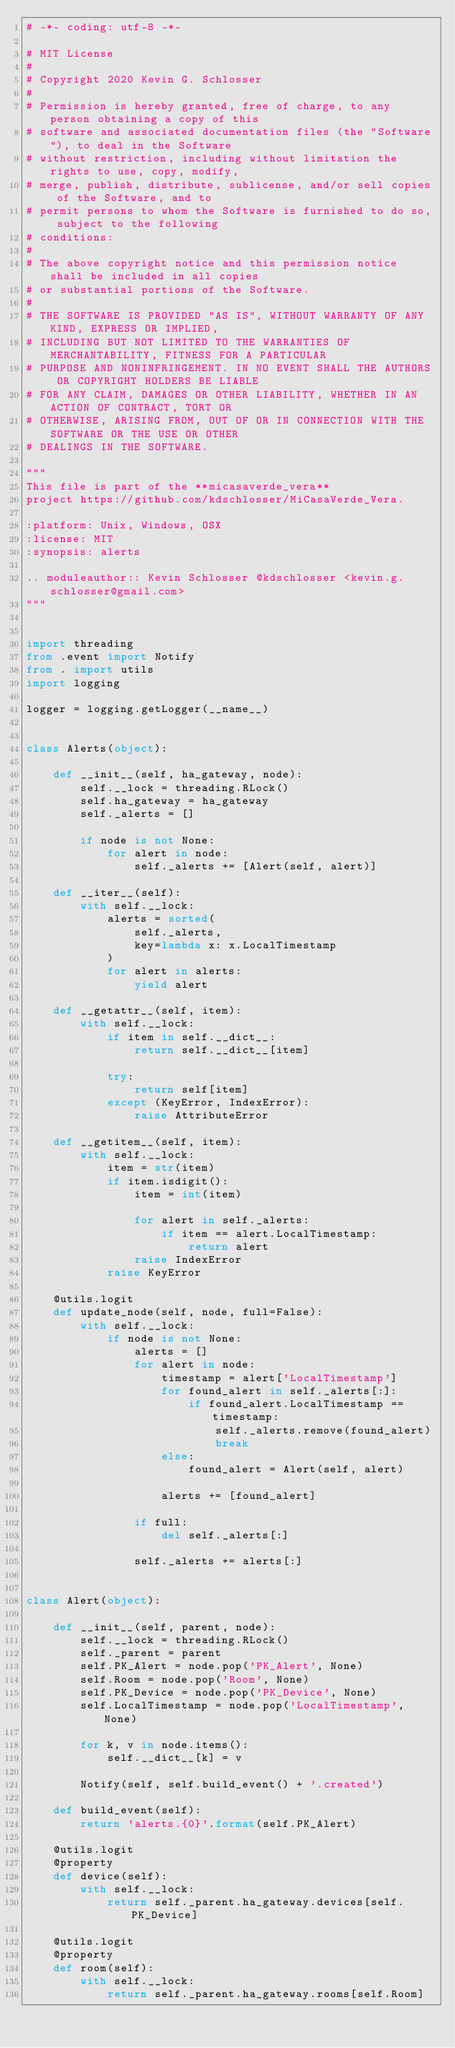Convert code to text. <code><loc_0><loc_0><loc_500><loc_500><_Python_># -*- coding: utf-8 -*-

# MIT License
#
# Copyright 2020 Kevin G. Schlosser
#
# Permission is hereby granted, free of charge, to any person obtaining a copy of this
# software and associated documentation files (the "Software"), to deal in the Software
# without restriction, including without limitation the rights to use, copy, modify,
# merge, publish, distribute, sublicense, and/or sell copies of the Software, and to
# permit persons to whom the Software is furnished to do so, subject to the following
# conditions:
#
# The above copyright notice and this permission notice shall be included in all copies
# or substantial portions of the Software.
#
# THE SOFTWARE IS PROVIDED "AS IS", WITHOUT WARRANTY OF ANY KIND, EXPRESS OR IMPLIED,
# INCLUDING BUT NOT LIMITED TO THE WARRANTIES OF MERCHANTABILITY, FITNESS FOR A PARTICULAR
# PURPOSE AND NONINFRINGEMENT. IN NO EVENT SHALL THE AUTHORS OR COPYRIGHT HOLDERS BE LIABLE
# FOR ANY CLAIM, DAMAGES OR OTHER LIABILITY, WHETHER IN AN ACTION OF CONTRACT, TORT OR
# OTHERWISE, ARISING FROM, OUT OF OR IN CONNECTION WITH THE SOFTWARE OR THE USE OR OTHER
# DEALINGS IN THE SOFTWARE.

"""
This file is part of the **micasaverde_vera**
project https://github.com/kdschlosser/MiCasaVerde_Vera.

:platform: Unix, Windows, OSX
:license: MIT
:synopsis: alerts

.. moduleauthor:: Kevin Schlosser @kdschlosser <kevin.g.schlosser@gmail.com>
"""


import threading
from .event import Notify
from . import utils
import logging

logger = logging.getLogger(__name__)


class Alerts(object):

    def __init__(self, ha_gateway, node):
        self.__lock = threading.RLock()
        self.ha_gateway = ha_gateway
        self._alerts = []

        if node is not None:
            for alert in node:
                self._alerts += [Alert(self, alert)]

    def __iter__(self):
        with self.__lock:
            alerts = sorted(
                self._alerts,
                key=lambda x: x.LocalTimestamp
            )
            for alert in alerts:
                yield alert

    def __getattr__(self, item):
        with self.__lock:
            if item in self.__dict__:
                return self.__dict__[item]

            try:
                return self[item]
            except (KeyError, IndexError):
                raise AttributeError

    def __getitem__(self, item):
        with self.__lock:
            item = str(item)
            if item.isdigit():
                item = int(item)

                for alert in self._alerts:
                    if item == alert.LocalTimestamp:
                        return alert
                raise IndexError
            raise KeyError

    @utils.logit
    def update_node(self, node, full=False):
        with self.__lock:
            if node is not None:
                alerts = []
                for alert in node:
                    timestamp = alert['LocalTimestamp']
                    for found_alert in self._alerts[:]:
                        if found_alert.LocalTimestamp == timestamp:
                            self._alerts.remove(found_alert)
                            break
                    else:
                        found_alert = Alert(self, alert)

                    alerts += [found_alert]

                if full:
                    del self._alerts[:]

                self._alerts += alerts[:]


class Alert(object):

    def __init__(self, parent, node):
        self.__lock = threading.RLock()
        self._parent = parent
        self.PK_Alert = node.pop('PK_Alert', None)
        self.Room = node.pop('Room', None)
        self.PK_Device = node.pop('PK_Device', None)
        self.LocalTimestamp = node.pop('LocalTimestamp', None)

        for k, v in node.items():
            self.__dict__[k] = v

        Notify(self, self.build_event() + '.created')

    def build_event(self):
        return 'alerts.{0}'.format(self.PK_Alert)

    @utils.logit
    @property
    def device(self):
        with self.__lock:
            return self._parent.ha_gateway.devices[self.PK_Device]

    @utils.logit
    @property
    def room(self):
        with self.__lock:
            return self._parent.ha_gateway.rooms[self.Room]
</code> 